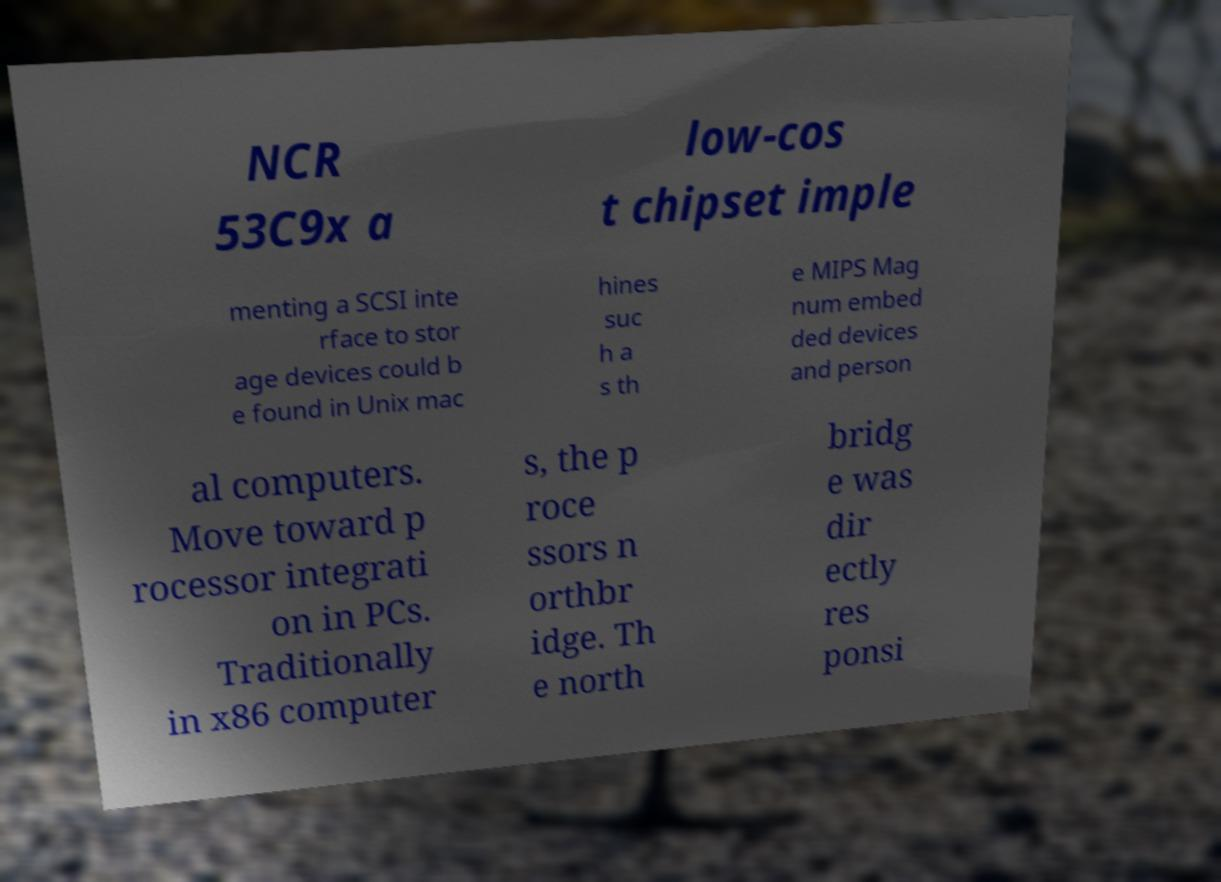Could you assist in decoding the text presented in this image and type it out clearly? NCR 53C9x a low-cos t chipset imple menting a SCSI inte rface to stor age devices could b e found in Unix mac hines suc h a s th e MIPS Mag num embed ded devices and person al computers. Move toward p rocessor integrati on in PCs. Traditionally in x86 computer s, the p roce ssors n orthbr idge. Th e north bridg e was dir ectly res ponsi 